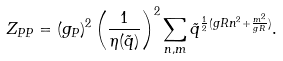Convert formula to latex. <formula><loc_0><loc_0><loc_500><loc_500>Z _ { P P } = ( g _ { P } ) ^ { 2 } \left ( \frac { 1 } { \eta { ( \tilde { q } ) } } \right ) ^ { 2 } \sum _ { n , m } \tilde { q } ^ { \frac { 1 } { 2 } ( g R n ^ { 2 } + \frac { m ^ { 2 } } { g R } ) } .</formula> 